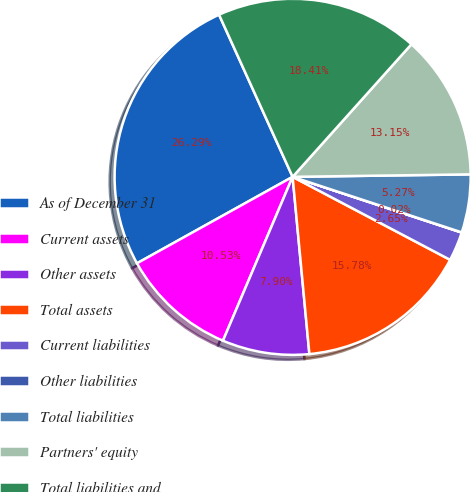Convert chart to OTSL. <chart><loc_0><loc_0><loc_500><loc_500><pie_chart><fcel>As of December 31<fcel>Current assets<fcel>Other assets<fcel>Total assets<fcel>Current liabilities<fcel>Other liabilities<fcel>Total liabilities<fcel>Partners' equity<fcel>Total liabilities and<nl><fcel>26.29%<fcel>10.53%<fcel>7.9%<fcel>15.78%<fcel>2.65%<fcel>0.02%<fcel>5.27%<fcel>13.15%<fcel>18.41%<nl></chart> 